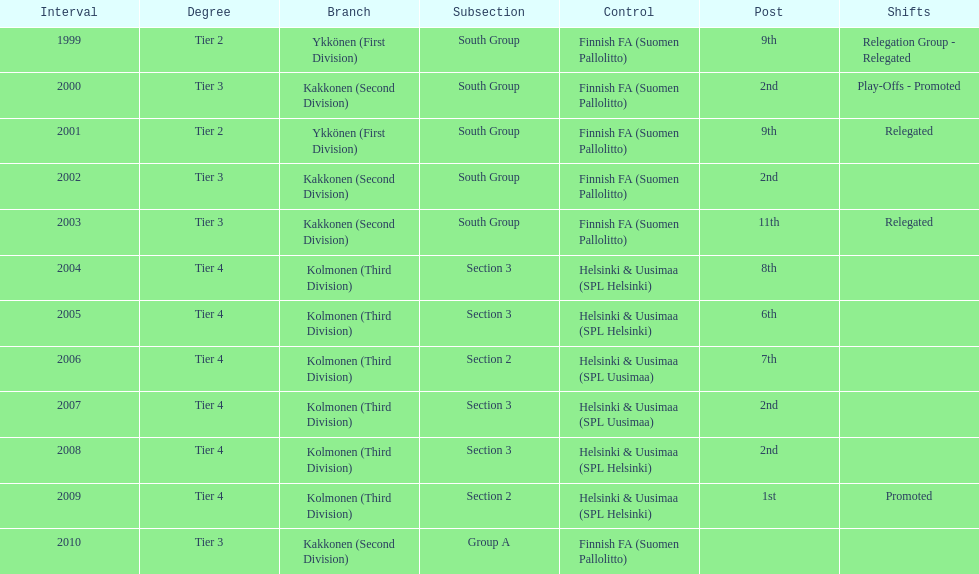What division were they in the most, section 3 or 2? 3. 